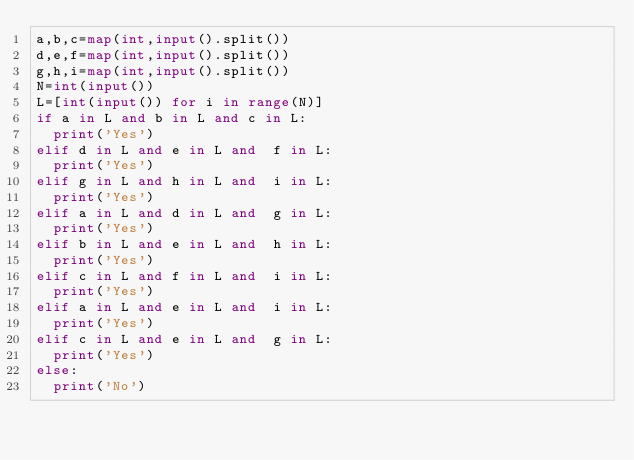Convert code to text. <code><loc_0><loc_0><loc_500><loc_500><_Python_>a,b,c=map(int,input().split())
d,e,f=map(int,input().split())
g,h,i=map(int,input().split())
N=int(input())
L=[int(input()) for i in range(N)]
if a in L and b in L and c in L:
  print('Yes')
elif d in L and e in L and  f in L:
  print('Yes')
elif g in L and h in L and  i in L:
  print('Yes')
elif a in L and d in L and  g in L:
  print('Yes')
elif b in L and e in L and  h in L:
  print('Yes')
elif c in L and f in L and  i in L:
  print('Yes')
elif a in L and e in L and  i in L:
  print('Yes')
elif c in L and e in L and  g in L:
  print('Yes')
else:
  print('No')
 </code> 